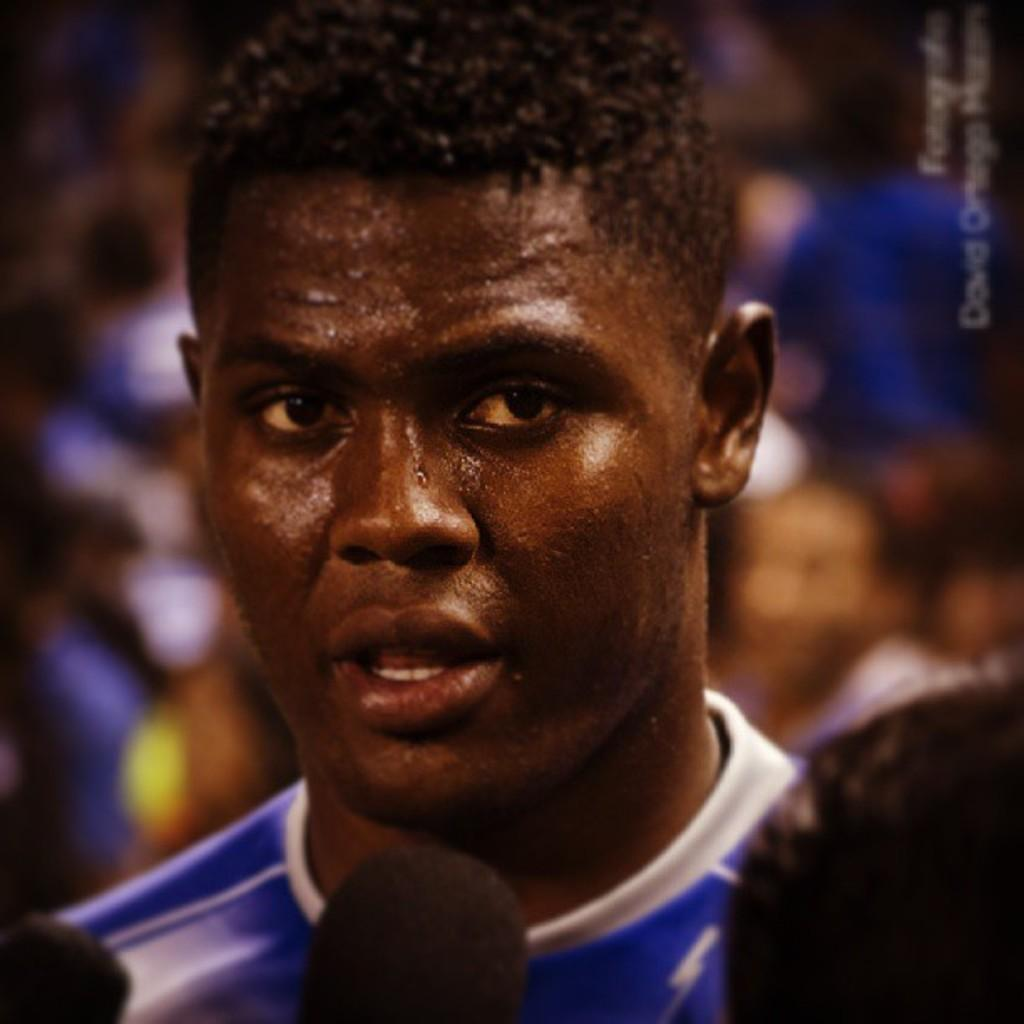Who or what can be seen in the image? There are people in the image. Can you describe the background of the image? The background is blurry. Is there any text visible in the image? Yes, there is some text in the top right hand corner of the image. What type of drain can be seen in the image? There is no drain present in the image. Is the image set in a foggy environment? The image does not indicate a foggy environment; the background is simply blurry. Can you see any prison bars in the image? There are no prison bars visible in the image. 